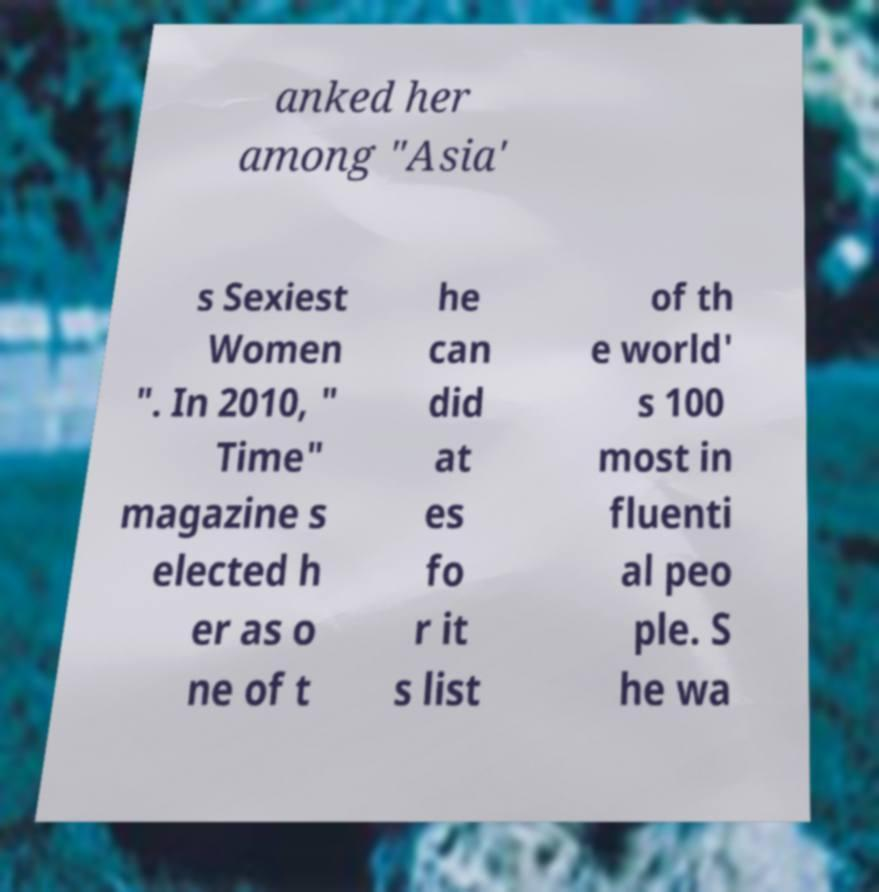I need the written content from this picture converted into text. Can you do that? anked her among "Asia' s Sexiest Women ". In 2010, " Time" magazine s elected h er as o ne of t he can did at es fo r it s list of th e world' s 100 most in fluenti al peo ple. S he wa 